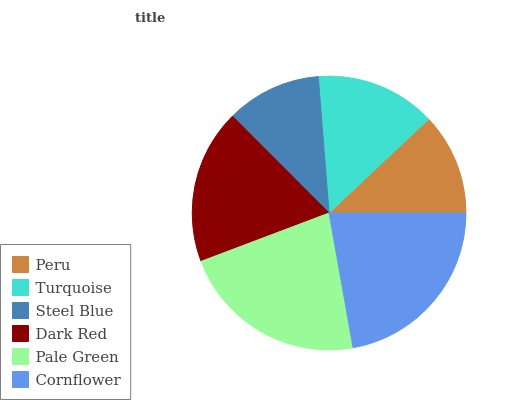Is Steel Blue the minimum?
Answer yes or no. Yes. Is Cornflower the maximum?
Answer yes or no. Yes. Is Turquoise the minimum?
Answer yes or no. No. Is Turquoise the maximum?
Answer yes or no. No. Is Turquoise greater than Peru?
Answer yes or no. Yes. Is Peru less than Turquoise?
Answer yes or no. Yes. Is Peru greater than Turquoise?
Answer yes or no. No. Is Turquoise less than Peru?
Answer yes or no. No. Is Dark Red the high median?
Answer yes or no. Yes. Is Turquoise the low median?
Answer yes or no. Yes. Is Peru the high median?
Answer yes or no. No. Is Cornflower the low median?
Answer yes or no. No. 